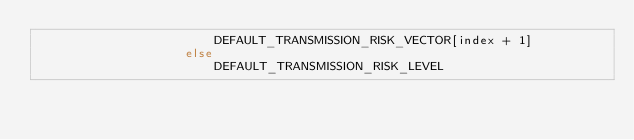Convert code to text. <code><loc_0><loc_0><loc_500><loc_500><_Kotlin_>                        DEFAULT_TRANSMISSION_RISK_VECTOR[index + 1]
                    else
                        DEFAULT_TRANSMISSION_RISK_LEVEL</code> 